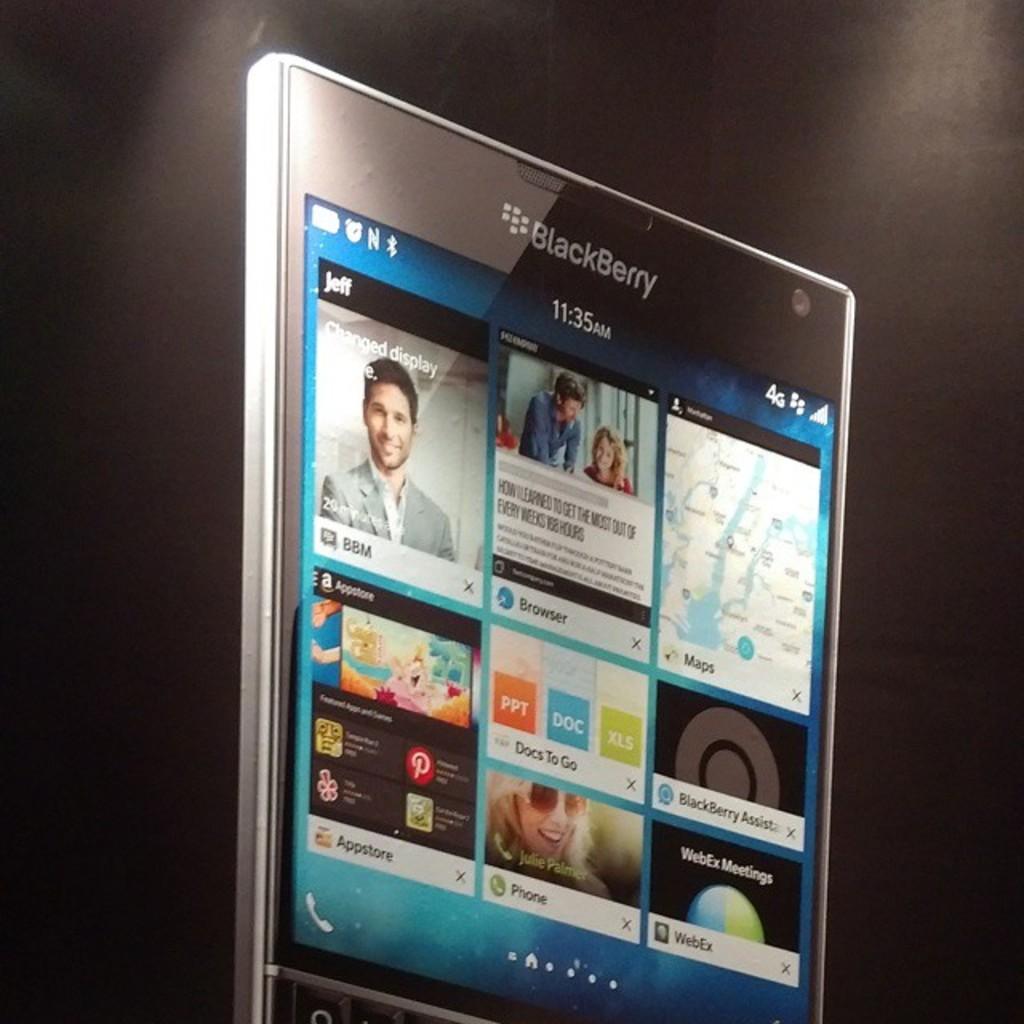What time is displayed on the phone?
Provide a succinct answer. 11:35. 